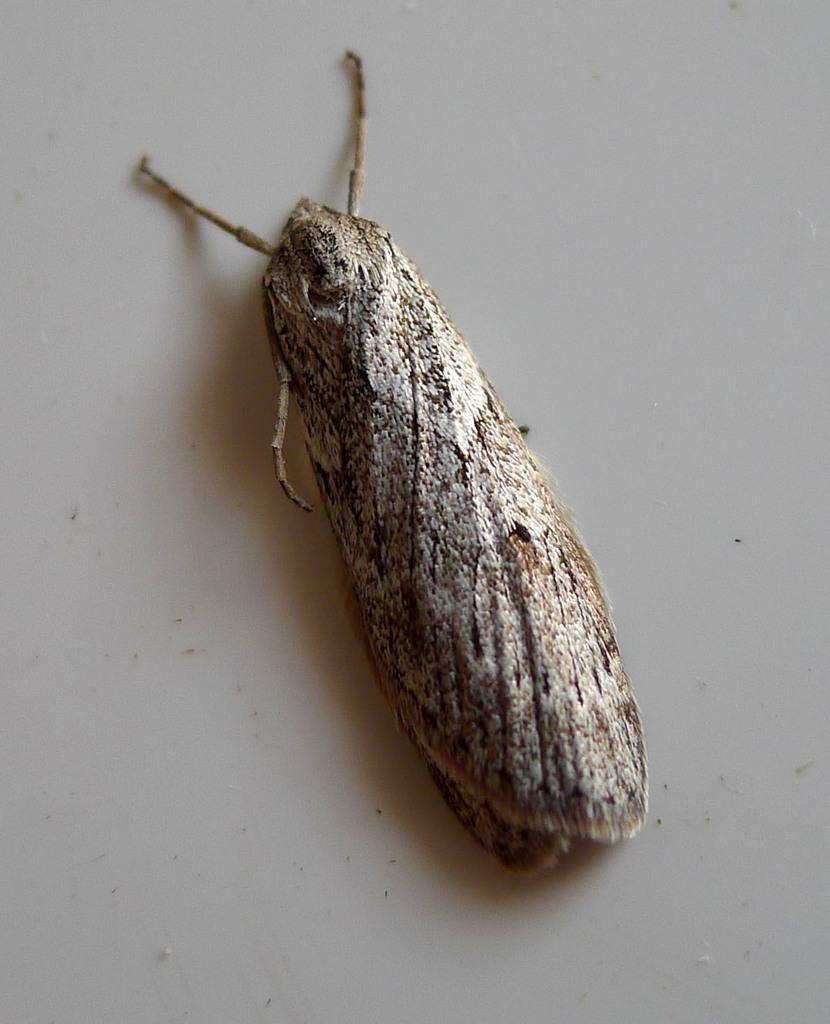What type of creature is present in the image? There is an insect in the image. What is the background or surface on which the insect is located? The insect is on a white surface. What organization does the insect belong to in the image? There is no indication in the image that the insect belongs to any organization. Who is the insect's friend in the image? There is no indication in the image that the insect has any friends. 